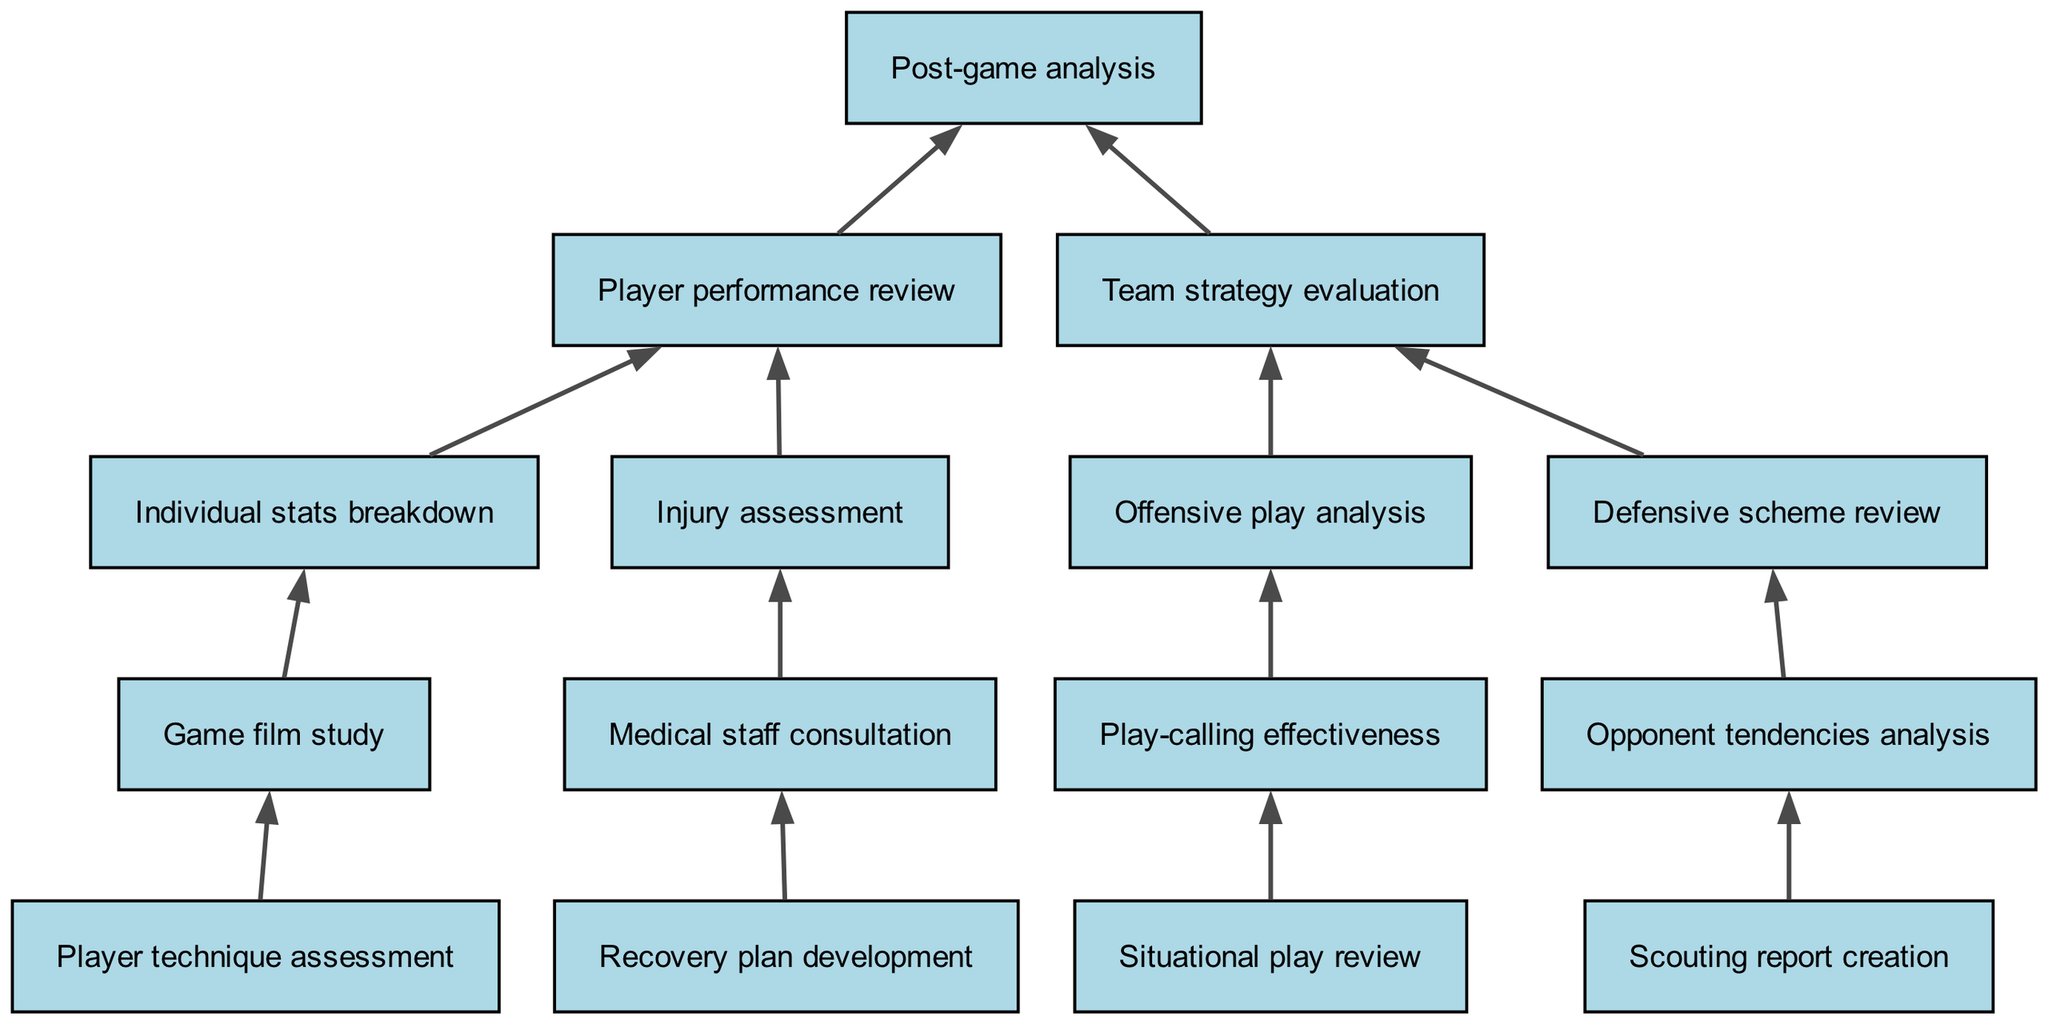What's the top node in the diagram? The top node represents the overall goal or outcome of the process, which here is "Post-game analysis". It is the highest level of the flow chart, indicating that everything below it contributes to this analysis.
Answer: Post-game analysis How many main branches are there stemming from the top node? Starting from the top node, there are two main branches leading to "Player performance review" and "Team strategy evaluation". This indicates two primary areas of focus in the analysis process.
Answer: 2 What is the direct child of "Player performance review"? The immediate descendants of "Player performance review" are "Individual stats breakdown" and "Injury assessment", which are key components to evaluate player performance.
Answer: Individual stats breakdown What node is related to medical aspects in the diagram? The node directly associated with medical aspects is "Medical staff consultation", which is part of the "Injury assessment". This indicates the impact of player injuries on game day preparation and analysis.
Answer: Medical staff consultation Which element focuses on offensive strategies? The node that emphasizes offensive strategies is "Offensive play analysis". This reflects the importance of analyzing plays that are specifically aimed at scoring points in games.
Answer: Offensive play analysis What is the lowest level node associated with player performance? The lowest node related to player performance is "Player technique assessment", which resides under "Individual stats breakdown". This illustrates a detailed level of analysis focusing solely on how players performed at a technical level.
Answer: Player technique assessment How does "Defensive scheme review" connect to the overall process? "Defensive scheme review" is connected as a sub-process under "Team strategy evaluation". This signifies its role in understanding how the team performed defensively throughout the game.
Answer: Team strategy evaluation What does "Scouting report creation" contribute to? "Scouting report creation" plays a critical role in evaluating "Opponent tendencies analysis", which is essential for preparing strategies against the opposing team.
Answer: Opponent tendencies analysis 